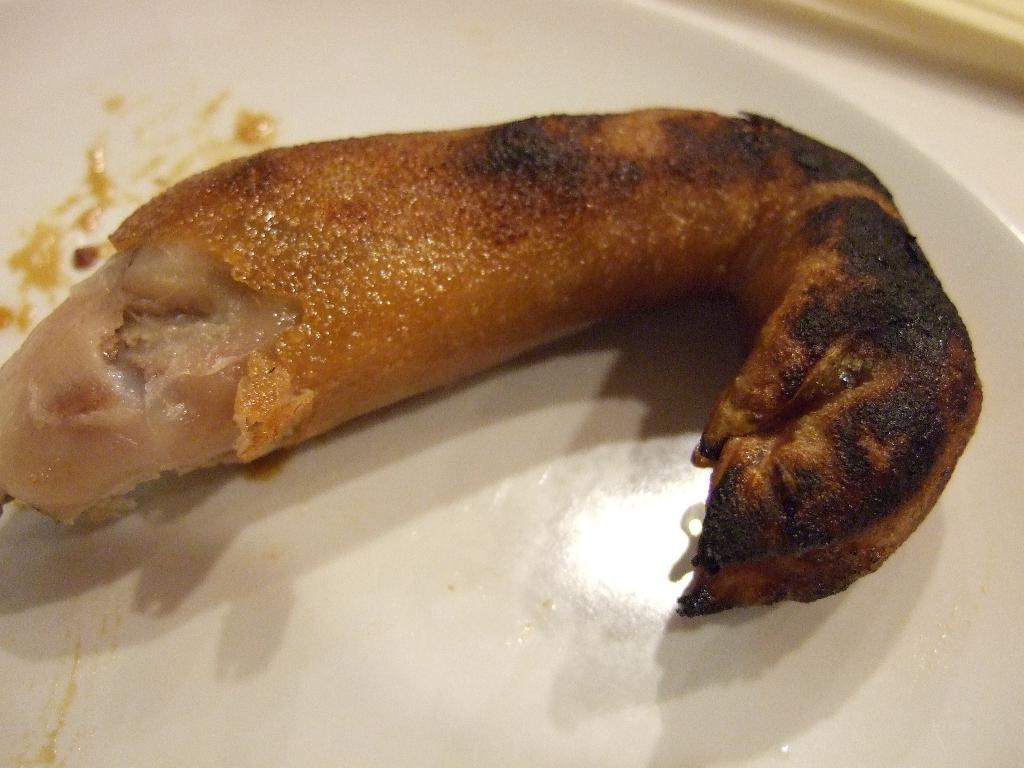What is there is a food item in the image, what is it? The food item in the image is not specified, but it is present. What is the color of the plate on which the food item is placed? The plate is white in color. What type of chain is wrapped around the cow in the image? There is no cow or chain present in the image; it only features a food item on a white plate. 